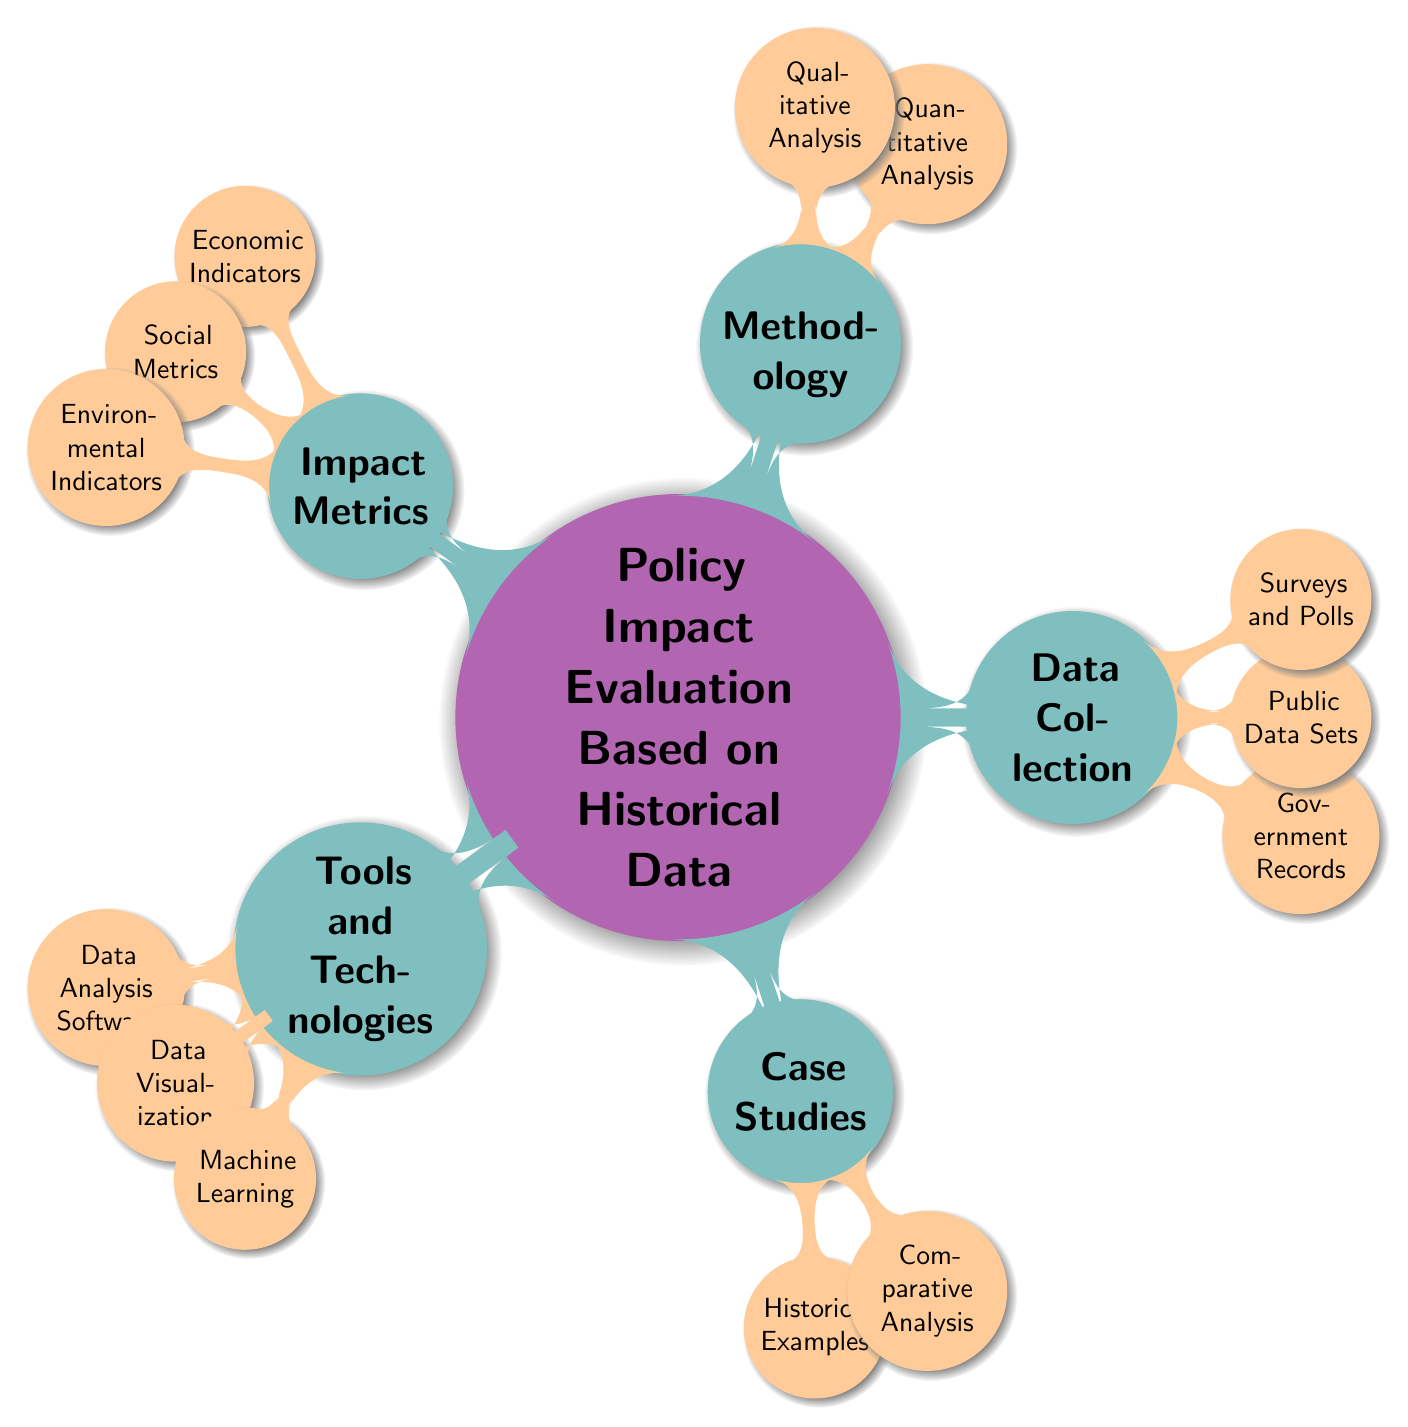What is the main topic of the mind map? The central node of the mind map contains the main topic, which is clearly labeled as "Policy Impact Evaluation Based on Historical Data."
Answer: Policy Impact Evaluation Based on Historical Data How many main branches are there? By reviewing the nodes directly connected to the central topic, we see five main branches: Data Collection, Methodology, Impact Metrics, Tools and Technologies, and Case Studies.
Answer: 5 What are the three types of data sources listed under Data Collection? Under the Data Collection branch, there are three sub-nodes: Government Records, Public Data Sets, and Surveys and Polls, which specify the sources of data used for policy impact evaluation.
Answer: Government Records, Public Data Sets, Surveys and Polls Which methodology involves qualitative analysis? The branch labeled 'Methodology' has two sub-nodes. 'Qualitative Analysis' clearly indicates the use of this method for analysis, distinguishing it from the quantitative methods listed there.
Answer: Qualitative Analysis What are the impact metrics categorized under Social Metrics? Looking at the 'Impact Metrics' branch, the 'Social Metrics' node does not specify particular metrics but indicates that they encompass various social-related measurements.
Answer: Healthcare Access, Education Levels Which tools are associated with data visualization? Within the 'Tools and Technologies' branch, the 'Data Visualization' node suggests which tools are used for visual representation of data. Specifically, examples include Tableau and Power BI, though these are not mentioned in the node itself but are a known purpose of this category.
Answer: Data Visualization What example is provided under Historical Examples in Case Studies? The 'Case Studies' branch includes a sub-node for 'Historical Examples,' specifically calling out the New Deal Programs as a notable historical reference for policy impact evaluation.
Answer: New Deal Programs Which analysis technique is mentioned under Quantitative Analysis? The 'Quantitative Analysis' node in the Methodology section indicates the use of 'Regression Analysis' as one of the techniques for quantitative evaluation of policy impacts.
Answer: Regression Analysis What is the purpose of the Machine Learning branch? The 'Machine Learning' node under the Tools and Technologies branch implies the utilization of machine learning techniques to analyze data and potentially forecast impacts, though it doesn't list specific applications.
Answer: Machine Learning 